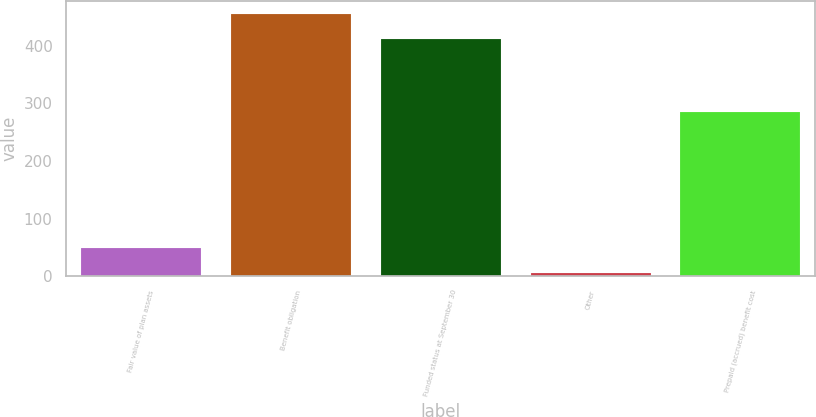<chart> <loc_0><loc_0><loc_500><loc_500><bar_chart><fcel>Fair value of plan assets<fcel>Benefit obligation<fcel>Funded status at September 30<fcel>Other<fcel>Prepaid (accrued) benefit cost<nl><fcel>48<fcel>454.8<fcel>412.9<fcel>6<fcel>286<nl></chart> 